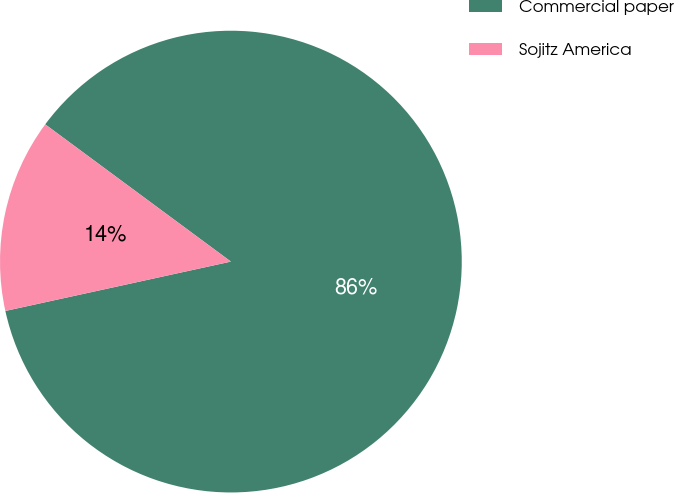Convert chart to OTSL. <chart><loc_0><loc_0><loc_500><loc_500><pie_chart><fcel>Commercial paper<fcel>Sojitz America<nl><fcel>86.44%<fcel>13.56%<nl></chart> 